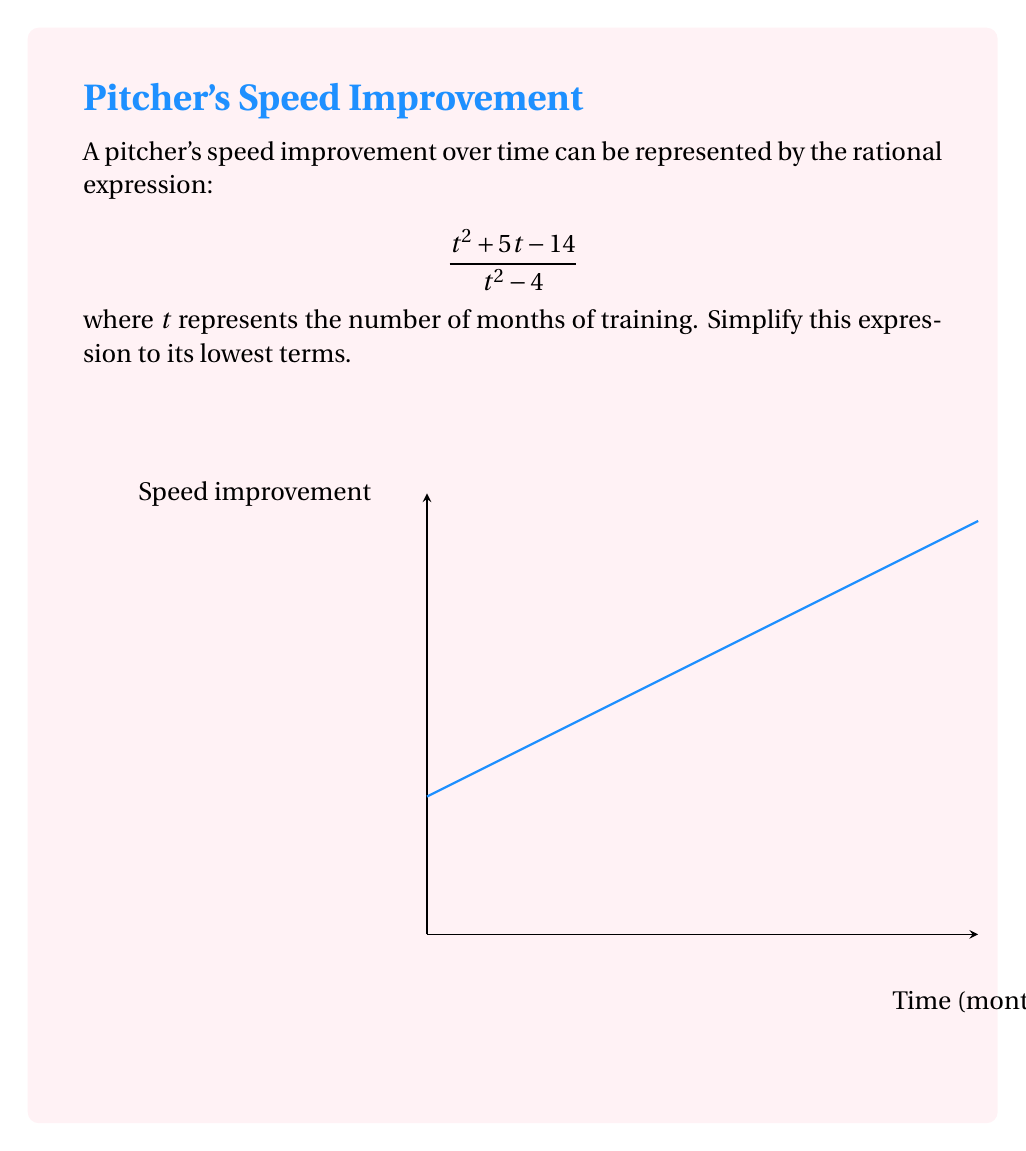Show me your answer to this math problem. Let's simplify this rational expression step by step:

1) First, we need to factor both the numerator and denominator:

   Numerator: $t^2 + 5t - 14 = (t+7)(t-2)$
   Denominator: $t^2 - 4 = (t+2)(t-2)$

2) Now our expression looks like this:

   $$\frac{(t+7)(t-2)}{(t+2)(t-2)}$$

3) We can see that $(t-2)$ appears in both the numerator and denominator. We can cancel this factor:

   $$\frac{(t+7)\cancel{(t-2)}}{(t+2)\cancel{(t-2)}}$$

4) After canceling, we're left with:

   $$\frac{t+7}{t+2}$$

5) This fraction cannot be simplified further as there are no common factors between the numerator and denominator.

Therefore, the simplified expression is $\frac{t+7}{t+2}$.
Answer: $$\frac{t+7}{t+2}$$ 